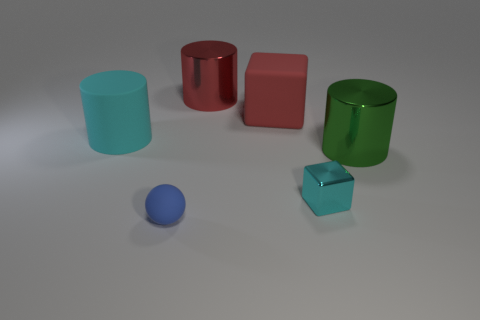Add 3 blue things. How many objects exist? 9 Subtract all cubes. How many objects are left? 4 Subtract all big shiny cylinders. Subtract all cubes. How many objects are left? 2 Add 3 big metal cylinders. How many big metal cylinders are left? 5 Add 4 purple balls. How many purple balls exist? 4 Subtract 0 brown cylinders. How many objects are left? 6 